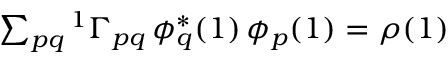<formula> <loc_0><loc_0><loc_500><loc_500>\begin{array} { r } { \sum _ { p q } { ^ { 1 } \Gamma } _ { p q } \, \phi _ { q } ^ { * } ( 1 ) \, \phi _ { p } ( 1 ) = \rho ( 1 ) \quad } \end{array}</formula> 